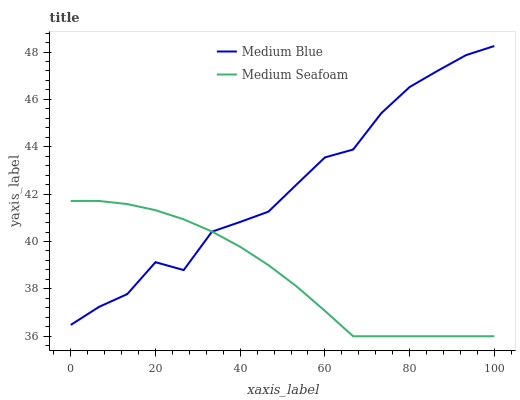Does Medium Seafoam have the minimum area under the curve?
Answer yes or no. Yes. Does Medium Blue have the maximum area under the curve?
Answer yes or no. Yes. Does Medium Seafoam have the maximum area under the curve?
Answer yes or no. No. Is Medium Seafoam the smoothest?
Answer yes or no. Yes. Is Medium Blue the roughest?
Answer yes or no. Yes. Is Medium Seafoam the roughest?
Answer yes or no. No. Does Medium Seafoam have the lowest value?
Answer yes or no. Yes. Does Medium Blue have the highest value?
Answer yes or no. Yes. Does Medium Seafoam have the highest value?
Answer yes or no. No. Does Medium Seafoam intersect Medium Blue?
Answer yes or no. Yes. Is Medium Seafoam less than Medium Blue?
Answer yes or no. No. Is Medium Seafoam greater than Medium Blue?
Answer yes or no. No. 